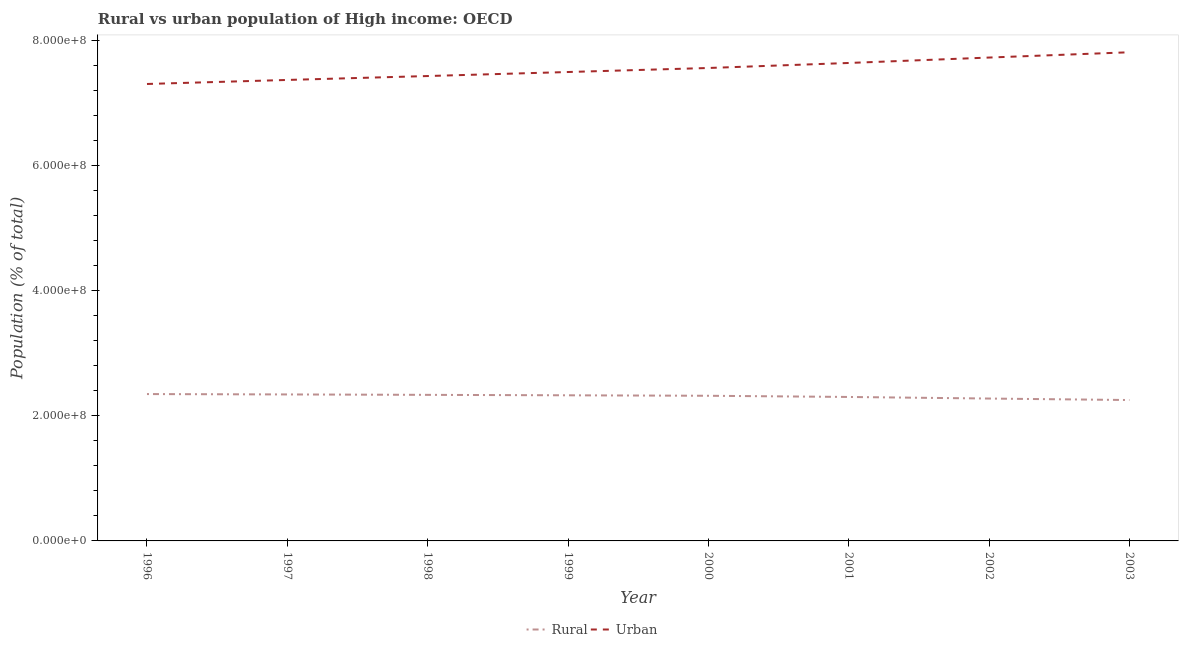Is the number of lines equal to the number of legend labels?
Your response must be concise. Yes. What is the rural population density in 1997?
Make the answer very short. 2.34e+08. Across all years, what is the maximum urban population density?
Offer a terse response. 7.82e+08. Across all years, what is the minimum rural population density?
Offer a terse response. 2.25e+08. In which year was the rural population density maximum?
Provide a succinct answer. 1996. What is the total urban population density in the graph?
Your answer should be very brief. 6.04e+09. What is the difference between the rural population density in 1996 and that in 1997?
Offer a terse response. 5.95e+05. What is the difference between the rural population density in 2000 and the urban population density in 1996?
Provide a succinct answer. -4.99e+08. What is the average rural population density per year?
Offer a very short reply. 2.31e+08. In the year 1998, what is the difference between the urban population density and rural population density?
Your answer should be very brief. 5.10e+08. What is the ratio of the urban population density in 1996 to that in 1998?
Your response must be concise. 0.98. Is the rural population density in 1996 less than that in 2001?
Make the answer very short. No. Is the difference between the urban population density in 1996 and 2002 greater than the difference between the rural population density in 1996 and 2002?
Your response must be concise. No. What is the difference between the highest and the second highest rural population density?
Keep it short and to the point. 5.95e+05. What is the difference between the highest and the lowest rural population density?
Your answer should be compact. 9.55e+06. In how many years, is the urban population density greater than the average urban population density taken over all years?
Your answer should be very brief. 4. Is the urban population density strictly less than the rural population density over the years?
Ensure brevity in your answer.  No. How many years are there in the graph?
Ensure brevity in your answer.  8. How are the legend labels stacked?
Your response must be concise. Horizontal. What is the title of the graph?
Your response must be concise. Rural vs urban population of High income: OECD. Does "Grants" appear as one of the legend labels in the graph?
Provide a succinct answer. No. What is the label or title of the Y-axis?
Keep it short and to the point. Population (% of total). What is the Population (% of total) in Rural in 1996?
Provide a succinct answer. 2.35e+08. What is the Population (% of total) in Urban in 1996?
Your answer should be very brief. 7.31e+08. What is the Population (% of total) of Rural in 1997?
Make the answer very short. 2.34e+08. What is the Population (% of total) in Urban in 1997?
Make the answer very short. 7.38e+08. What is the Population (% of total) of Rural in 1998?
Make the answer very short. 2.34e+08. What is the Population (% of total) in Urban in 1998?
Offer a terse response. 7.44e+08. What is the Population (% of total) of Rural in 1999?
Your response must be concise. 2.33e+08. What is the Population (% of total) in Urban in 1999?
Make the answer very short. 7.50e+08. What is the Population (% of total) of Rural in 2000?
Give a very brief answer. 2.32e+08. What is the Population (% of total) in Urban in 2000?
Your response must be concise. 7.57e+08. What is the Population (% of total) of Rural in 2001?
Offer a very short reply. 2.30e+08. What is the Population (% of total) of Urban in 2001?
Offer a very short reply. 7.65e+08. What is the Population (% of total) of Rural in 2002?
Offer a terse response. 2.28e+08. What is the Population (% of total) of Urban in 2002?
Ensure brevity in your answer.  7.73e+08. What is the Population (% of total) of Rural in 2003?
Provide a short and direct response. 2.25e+08. What is the Population (% of total) in Urban in 2003?
Your answer should be compact. 7.82e+08. Across all years, what is the maximum Population (% of total) of Rural?
Make the answer very short. 2.35e+08. Across all years, what is the maximum Population (% of total) of Urban?
Ensure brevity in your answer.  7.82e+08. Across all years, what is the minimum Population (% of total) of Rural?
Provide a succinct answer. 2.25e+08. Across all years, what is the minimum Population (% of total) in Urban?
Your response must be concise. 7.31e+08. What is the total Population (% of total) in Rural in the graph?
Offer a terse response. 1.85e+09. What is the total Population (% of total) in Urban in the graph?
Your answer should be compact. 6.04e+09. What is the difference between the Population (% of total) in Rural in 1996 and that in 1997?
Provide a succinct answer. 5.95e+05. What is the difference between the Population (% of total) of Urban in 1996 and that in 1997?
Offer a very short reply. -6.45e+06. What is the difference between the Population (% of total) in Rural in 1996 and that in 1998?
Your answer should be compact. 1.26e+06. What is the difference between the Population (% of total) of Urban in 1996 and that in 1998?
Your answer should be compact. -1.27e+07. What is the difference between the Population (% of total) of Rural in 1996 and that in 1999?
Make the answer very short. 1.97e+06. What is the difference between the Population (% of total) of Urban in 1996 and that in 1999?
Keep it short and to the point. -1.91e+07. What is the difference between the Population (% of total) of Rural in 1996 and that in 2000?
Make the answer very short. 2.72e+06. What is the difference between the Population (% of total) of Urban in 1996 and that in 2000?
Make the answer very short. -2.56e+07. What is the difference between the Population (% of total) in Rural in 1996 and that in 2001?
Provide a short and direct response. 4.63e+06. What is the difference between the Population (% of total) of Urban in 1996 and that in 2001?
Give a very brief answer. -3.36e+07. What is the difference between the Population (% of total) in Rural in 1996 and that in 2002?
Your answer should be very brief. 7.17e+06. What is the difference between the Population (% of total) of Urban in 1996 and that in 2002?
Your answer should be very brief. -4.23e+07. What is the difference between the Population (% of total) in Rural in 1996 and that in 2003?
Keep it short and to the point. 9.55e+06. What is the difference between the Population (% of total) of Urban in 1996 and that in 2003?
Your response must be concise. -5.07e+07. What is the difference between the Population (% of total) of Rural in 1997 and that in 1998?
Your answer should be compact. 6.63e+05. What is the difference between the Population (% of total) in Urban in 1997 and that in 1998?
Your response must be concise. -6.25e+06. What is the difference between the Population (% of total) of Rural in 1997 and that in 1999?
Offer a terse response. 1.38e+06. What is the difference between the Population (% of total) in Urban in 1997 and that in 1999?
Give a very brief answer. -1.27e+07. What is the difference between the Population (% of total) in Rural in 1997 and that in 2000?
Your answer should be compact. 2.13e+06. What is the difference between the Population (% of total) in Urban in 1997 and that in 2000?
Offer a terse response. -1.91e+07. What is the difference between the Population (% of total) of Rural in 1997 and that in 2001?
Keep it short and to the point. 4.04e+06. What is the difference between the Population (% of total) in Urban in 1997 and that in 2001?
Keep it short and to the point. -2.72e+07. What is the difference between the Population (% of total) in Rural in 1997 and that in 2002?
Keep it short and to the point. 6.57e+06. What is the difference between the Population (% of total) in Urban in 1997 and that in 2002?
Make the answer very short. -3.58e+07. What is the difference between the Population (% of total) in Rural in 1997 and that in 2003?
Your response must be concise. 8.95e+06. What is the difference between the Population (% of total) in Urban in 1997 and that in 2003?
Offer a very short reply. -4.43e+07. What is the difference between the Population (% of total) in Rural in 1998 and that in 1999?
Keep it short and to the point. 7.17e+05. What is the difference between the Population (% of total) of Urban in 1998 and that in 1999?
Your answer should be compact. -6.43e+06. What is the difference between the Population (% of total) in Rural in 1998 and that in 2000?
Your answer should be compact. 1.47e+06. What is the difference between the Population (% of total) of Urban in 1998 and that in 2000?
Your answer should be compact. -1.29e+07. What is the difference between the Population (% of total) of Rural in 1998 and that in 2001?
Give a very brief answer. 3.37e+06. What is the difference between the Population (% of total) in Urban in 1998 and that in 2001?
Your response must be concise. -2.09e+07. What is the difference between the Population (% of total) in Rural in 1998 and that in 2002?
Your answer should be very brief. 5.91e+06. What is the difference between the Population (% of total) of Urban in 1998 and that in 2002?
Provide a succinct answer. -2.96e+07. What is the difference between the Population (% of total) of Rural in 1998 and that in 2003?
Your response must be concise. 8.29e+06. What is the difference between the Population (% of total) of Urban in 1998 and that in 2003?
Provide a short and direct response. -3.80e+07. What is the difference between the Population (% of total) in Rural in 1999 and that in 2000?
Offer a terse response. 7.49e+05. What is the difference between the Population (% of total) of Urban in 1999 and that in 2000?
Your answer should be compact. -6.44e+06. What is the difference between the Population (% of total) in Rural in 1999 and that in 2001?
Your response must be concise. 2.66e+06. What is the difference between the Population (% of total) of Urban in 1999 and that in 2001?
Keep it short and to the point. -1.45e+07. What is the difference between the Population (% of total) in Rural in 1999 and that in 2002?
Your answer should be compact. 5.19e+06. What is the difference between the Population (% of total) in Urban in 1999 and that in 2002?
Make the answer very short. -2.31e+07. What is the difference between the Population (% of total) of Rural in 1999 and that in 2003?
Offer a terse response. 7.57e+06. What is the difference between the Population (% of total) of Urban in 1999 and that in 2003?
Offer a very short reply. -3.16e+07. What is the difference between the Population (% of total) in Rural in 2000 and that in 2001?
Your response must be concise. 1.91e+06. What is the difference between the Population (% of total) of Urban in 2000 and that in 2001?
Your answer should be very brief. -8.04e+06. What is the difference between the Population (% of total) in Rural in 2000 and that in 2002?
Your answer should be very brief. 4.44e+06. What is the difference between the Population (% of total) in Urban in 2000 and that in 2002?
Keep it short and to the point. -1.67e+07. What is the difference between the Population (% of total) in Rural in 2000 and that in 2003?
Your response must be concise. 6.82e+06. What is the difference between the Population (% of total) of Urban in 2000 and that in 2003?
Offer a very short reply. -2.52e+07. What is the difference between the Population (% of total) of Rural in 2001 and that in 2002?
Offer a very short reply. 2.54e+06. What is the difference between the Population (% of total) in Urban in 2001 and that in 2002?
Give a very brief answer. -8.67e+06. What is the difference between the Population (% of total) in Rural in 2001 and that in 2003?
Keep it short and to the point. 4.91e+06. What is the difference between the Population (% of total) of Urban in 2001 and that in 2003?
Your answer should be very brief. -1.71e+07. What is the difference between the Population (% of total) in Rural in 2002 and that in 2003?
Your response must be concise. 2.38e+06. What is the difference between the Population (% of total) in Urban in 2002 and that in 2003?
Offer a terse response. -8.46e+06. What is the difference between the Population (% of total) of Rural in 1996 and the Population (% of total) of Urban in 1997?
Make the answer very short. -5.03e+08. What is the difference between the Population (% of total) in Rural in 1996 and the Population (% of total) in Urban in 1998?
Give a very brief answer. -5.09e+08. What is the difference between the Population (% of total) in Rural in 1996 and the Population (% of total) in Urban in 1999?
Your answer should be compact. -5.15e+08. What is the difference between the Population (% of total) in Rural in 1996 and the Population (% of total) in Urban in 2000?
Ensure brevity in your answer.  -5.22e+08. What is the difference between the Population (% of total) of Rural in 1996 and the Population (% of total) of Urban in 2001?
Your answer should be very brief. -5.30e+08. What is the difference between the Population (% of total) in Rural in 1996 and the Population (% of total) in Urban in 2002?
Your answer should be compact. -5.38e+08. What is the difference between the Population (% of total) in Rural in 1996 and the Population (% of total) in Urban in 2003?
Offer a very short reply. -5.47e+08. What is the difference between the Population (% of total) of Rural in 1997 and the Population (% of total) of Urban in 1998?
Your answer should be very brief. -5.09e+08. What is the difference between the Population (% of total) in Rural in 1997 and the Population (% of total) in Urban in 1999?
Provide a succinct answer. -5.16e+08. What is the difference between the Population (% of total) of Rural in 1997 and the Population (% of total) of Urban in 2000?
Provide a short and direct response. -5.22e+08. What is the difference between the Population (% of total) of Rural in 1997 and the Population (% of total) of Urban in 2001?
Ensure brevity in your answer.  -5.30e+08. What is the difference between the Population (% of total) of Rural in 1997 and the Population (% of total) of Urban in 2002?
Give a very brief answer. -5.39e+08. What is the difference between the Population (% of total) of Rural in 1997 and the Population (% of total) of Urban in 2003?
Your answer should be compact. -5.47e+08. What is the difference between the Population (% of total) in Rural in 1998 and the Population (% of total) in Urban in 1999?
Make the answer very short. -5.17e+08. What is the difference between the Population (% of total) in Rural in 1998 and the Population (% of total) in Urban in 2000?
Offer a terse response. -5.23e+08. What is the difference between the Population (% of total) in Rural in 1998 and the Population (% of total) in Urban in 2001?
Give a very brief answer. -5.31e+08. What is the difference between the Population (% of total) in Rural in 1998 and the Population (% of total) in Urban in 2002?
Provide a short and direct response. -5.40e+08. What is the difference between the Population (% of total) of Rural in 1998 and the Population (% of total) of Urban in 2003?
Provide a succinct answer. -5.48e+08. What is the difference between the Population (% of total) in Rural in 1999 and the Population (% of total) in Urban in 2000?
Offer a terse response. -5.24e+08. What is the difference between the Population (% of total) in Rural in 1999 and the Population (% of total) in Urban in 2001?
Give a very brief answer. -5.32e+08. What is the difference between the Population (% of total) in Rural in 1999 and the Population (% of total) in Urban in 2002?
Provide a succinct answer. -5.40e+08. What is the difference between the Population (% of total) of Rural in 1999 and the Population (% of total) of Urban in 2003?
Provide a succinct answer. -5.49e+08. What is the difference between the Population (% of total) of Rural in 2000 and the Population (% of total) of Urban in 2001?
Ensure brevity in your answer.  -5.32e+08. What is the difference between the Population (% of total) of Rural in 2000 and the Population (% of total) of Urban in 2002?
Keep it short and to the point. -5.41e+08. What is the difference between the Population (% of total) in Rural in 2000 and the Population (% of total) in Urban in 2003?
Provide a succinct answer. -5.50e+08. What is the difference between the Population (% of total) of Rural in 2001 and the Population (% of total) of Urban in 2002?
Keep it short and to the point. -5.43e+08. What is the difference between the Population (% of total) of Rural in 2001 and the Population (% of total) of Urban in 2003?
Provide a succinct answer. -5.52e+08. What is the difference between the Population (% of total) of Rural in 2002 and the Population (% of total) of Urban in 2003?
Provide a short and direct response. -5.54e+08. What is the average Population (% of total) of Rural per year?
Your answer should be very brief. 2.31e+08. What is the average Population (% of total) of Urban per year?
Ensure brevity in your answer.  7.55e+08. In the year 1996, what is the difference between the Population (% of total) of Rural and Population (% of total) of Urban?
Ensure brevity in your answer.  -4.96e+08. In the year 1997, what is the difference between the Population (% of total) in Rural and Population (% of total) in Urban?
Provide a succinct answer. -5.03e+08. In the year 1998, what is the difference between the Population (% of total) in Rural and Population (% of total) in Urban?
Provide a succinct answer. -5.10e+08. In the year 1999, what is the difference between the Population (% of total) in Rural and Population (% of total) in Urban?
Provide a succinct answer. -5.17e+08. In the year 2000, what is the difference between the Population (% of total) in Rural and Population (% of total) in Urban?
Offer a very short reply. -5.24e+08. In the year 2001, what is the difference between the Population (% of total) of Rural and Population (% of total) of Urban?
Ensure brevity in your answer.  -5.34e+08. In the year 2002, what is the difference between the Population (% of total) of Rural and Population (% of total) of Urban?
Ensure brevity in your answer.  -5.46e+08. In the year 2003, what is the difference between the Population (% of total) of Rural and Population (% of total) of Urban?
Your response must be concise. -5.56e+08. What is the ratio of the Population (% of total) in Rural in 1996 to that in 1997?
Give a very brief answer. 1. What is the ratio of the Population (% of total) in Rural in 1996 to that in 1998?
Provide a succinct answer. 1.01. What is the ratio of the Population (% of total) of Urban in 1996 to that in 1998?
Your response must be concise. 0.98. What is the ratio of the Population (% of total) of Rural in 1996 to that in 1999?
Keep it short and to the point. 1.01. What is the ratio of the Population (% of total) of Urban in 1996 to that in 1999?
Offer a very short reply. 0.97. What is the ratio of the Population (% of total) in Rural in 1996 to that in 2000?
Provide a short and direct response. 1.01. What is the ratio of the Population (% of total) in Urban in 1996 to that in 2000?
Your response must be concise. 0.97. What is the ratio of the Population (% of total) in Rural in 1996 to that in 2001?
Provide a succinct answer. 1.02. What is the ratio of the Population (% of total) in Urban in 1996 to that in 2001?
Your answer should be very brief. 0.96. What is the ratio of the Population (% of total) in Rural in 1996 to that in 2002?
Ensure brevity in your answer.  1.03. What is the ratio of the Population (% of total) in Urban in 1996 to that in 2002?
Give a very brief answer. 0.95. What is the ratio of the Population (% of total) in Rural in 1996 to that in 2003?
Give a very brief answer. 1.04. What is the ratio of the Population (% of total) of Urban in 1996 to that in 2003?
Keep it short and to the point. 0.94. What is the ratio of the Population (% of total) of Urban in 1997 to that in 1998?
Offer a terse response. 0.99. What is the ratio of the Population (% of total) of Rural in 1997 to that in 1999?
Your answer should be compact. 1.01. What is the ratio of the Population (% of total) in Urban in 1997 to that in 1999?
Offer a very short reply. 0.98. What is the ratio of the Population (% of total) of Rural in 1997 to that in 2000?
Keep it short and to the point. 1.01. What is the ratio of the Population (% of total) in Urban in 1997 to that in 2000?
Provide a succinct answer. 0.97. What is the ratio of the Population (% of total) in Rural in 1997 to that in 2001?
Your response must be concise. 1.02. What is the ratio of the Population (% of total) in Urban in 1997 to that in 2001?
Your answer should be very brief. 0.96. What is the ratio of the Population (% of total) of Rural in 1997 to that in 2002?
Your answer should be compact. 1.03. What is the ratio of the Population (% of total) of Urban in 1997 to that in 2002?
Make the answer very short. 0.95. What is the ratio of the Population (% of total) in Rural in 1997 to that in 2003?
Provide a succinct answer. 1.04. What is the ratio of the Population (% of total) in Urban in 1997 to that in 2003?
Your answer should be compact. 0.94. What is the ratio of the Population (% of total) of Rural in 1998 to that in 1999?
Your response must be concise. 1. What is the ratio of the Population (% of total) in Rural in 1998 to that in 2000?
Give a very brief answer. 1.01. What is the ratio of the Population (% of total) in Rural in 1998 to that in 2001?
Provide a short and direct response. 1.01. What is the ratio of the Population (% of total) in Urban in 1998 to that in 2001?
Give a very brief answer. 0.97. What is the ratio of the Population (% of total) in Rural in 1998 to that in 2002?
Your response must be concise. 1.03. What is the ratio of the Population (% of total) of Urban in 1998 to that in 2002?
Offer a very short reply. 0.96. What is the ratio of the Population (% of total) of Rural in 1998 to that in 2003?
Keep it short and to the point. 1.04. What is the ratio of the Population (% of total) of Urban in 1998 to that in 2003?
Your answer should be compact. 0.95. What is the ratio of the Population (% of total) in Rural in 1999 to that in 2000?
Offer a very short reply. 1. What is the ratio of the Population (% of total) in Rural in 1999 to that in 2001?
Offer a terse response. 1.01. What is the ratio of the Population (% of total) in Urban in 1999 to that in 2001?
Provide a succinct answer. 0.98. What is the ratio of the Population (% of total) of Rural in 1999 to that in 2002?
Provide a short and direct response. 1.02. What is the ratio of the Population (% of total) of Urban in 1999 to that in 2002?
Provide a short and direct response. 0.97. What is the ratio of the Population (% of total) in Rural in 1999 to that in 2003?
Give a very brief answer. 1.03. What is the ratio of the Population (% of total) of Urban in 1999 to that in 2003?
Your answer should be compact. 0.96. What is the ratio of the Population (% of total) of Rural in 2000 to that in 2001?
Provide a succinct answer. 1.01. What is the ratio of the Population (% of total) of Rural in 2000 to that in 2002?
Ensure brevity in your answer.  1.02. What is the ratio of the Population (% of total) in Urban in 2000 to that in 2002?
Provide a short and direct response. 0.98. What is the ratio of the Population (% of total) in Rural in 2000 to that in 2003?
Your answer should be compact. 1.03. What is the ratio of the Population (% of total) in Urban in 2000 to that in 2003?
Your response must be concise. 0.97. What is the ratio of the Population (% of total) of Rural in 2001 to that in 2002?
Keep it short and to the point. 1.01. What is the ratio of the Population (% of total) of Rural in 2001 to that in 2003?
Give a very brief answer. 1.02. What is the ratio of the Population (% of total) of Urban in 2001 to that in 2003?
Offer a terse response. 0.98. What is the ratio of the Population (% of total) in Rural in 2002 to that in 2003?
Offer a very short reply. 1.01. What is the difference between the highest and the second highest Population (% of total) in Rural?
Your answer should be very brief. 5.95e+05. What is the difference between the highest and the second highest Population (% of total) in Urban?
Provide a short and direct response. 8.46e+06. What is the difference between the highest and the lowest Population (% of total) in Rural?
Offer a very short reply. 9.55e+06. What is the difference between the highest and the lowest Population (% of total) in Urban?
Offer a very short reply. 5.07e+07. 